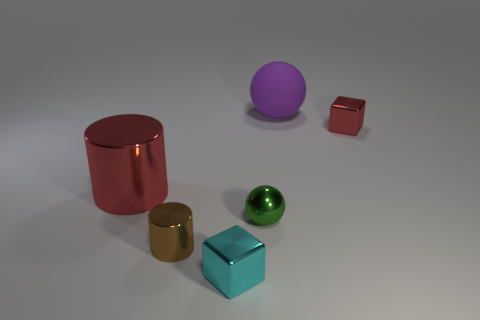The object that is the same color as the big cylinder is what shape?
Your response must be concise. Cube. Is there a cylinder that has the same color as the shiny ball?
Your answer should be compact. No. What material is the big purple thing?
Give a very brief answer. Rubber. What number of tiny red balls are there?
Your answer should be compact. 0. There is a tiny metallic object behind the large red shiny object; does it have the same color as the large object that is left of the purple rubber thing?
Give a very brief answer. Yes. How many other things are the same size as the green shiny object?
Provide a succinct answer. 3. There is a small metal cube left of the big purple thing; what is its color?
Give a very brief answer. Cyan. Does the cylinder left of the brown object have the same material as the tiny ball?
Your answer should be compact. Yes. What number of tiny things are both to the left of the purple rubber object and right of the tiny metallic cylinder?
Make the answer very short. 2. What is the color of the tiny shiny thing that is behind the red metallic thing that is in front of the small shiny thing on the right side of the big rubber object?
Provide a short and direct response. Red. 